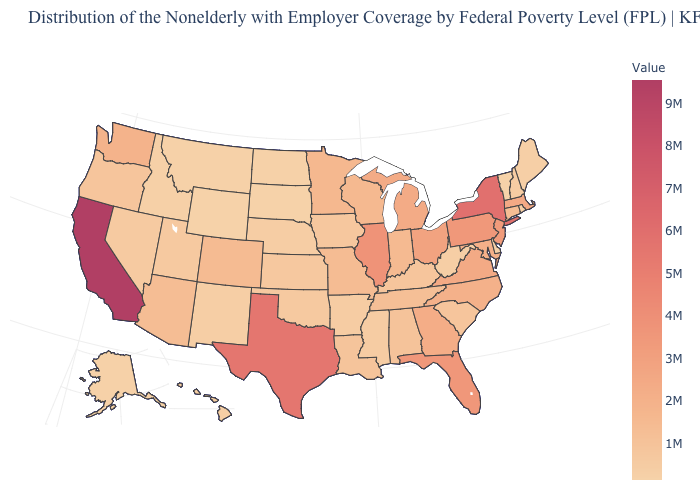Which states have the lowest value in the USA?
Give a very brief answer. Wyoming. Which states have the highest value in the USA?
Short answer required. California. Does the map have missing data?
Be succinct. No. 